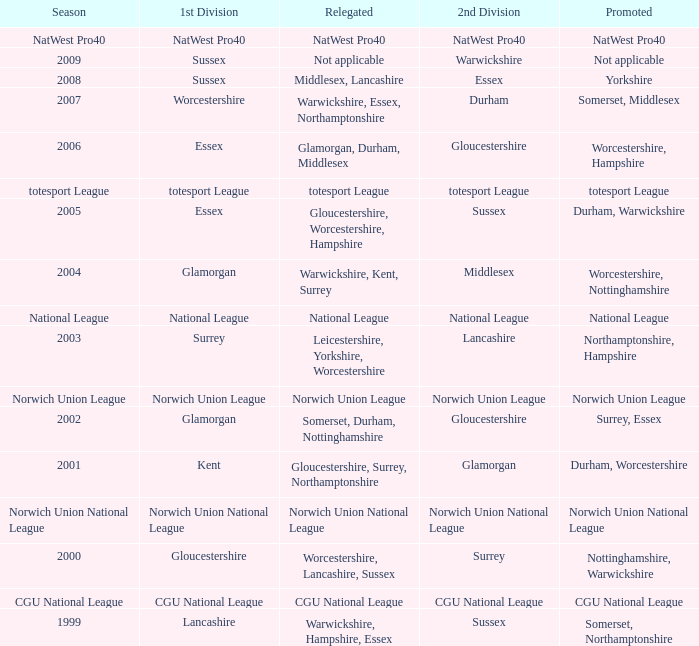What was relegated in the 2nd division of middlesex? Warwickshire, Kent, Surrey. 